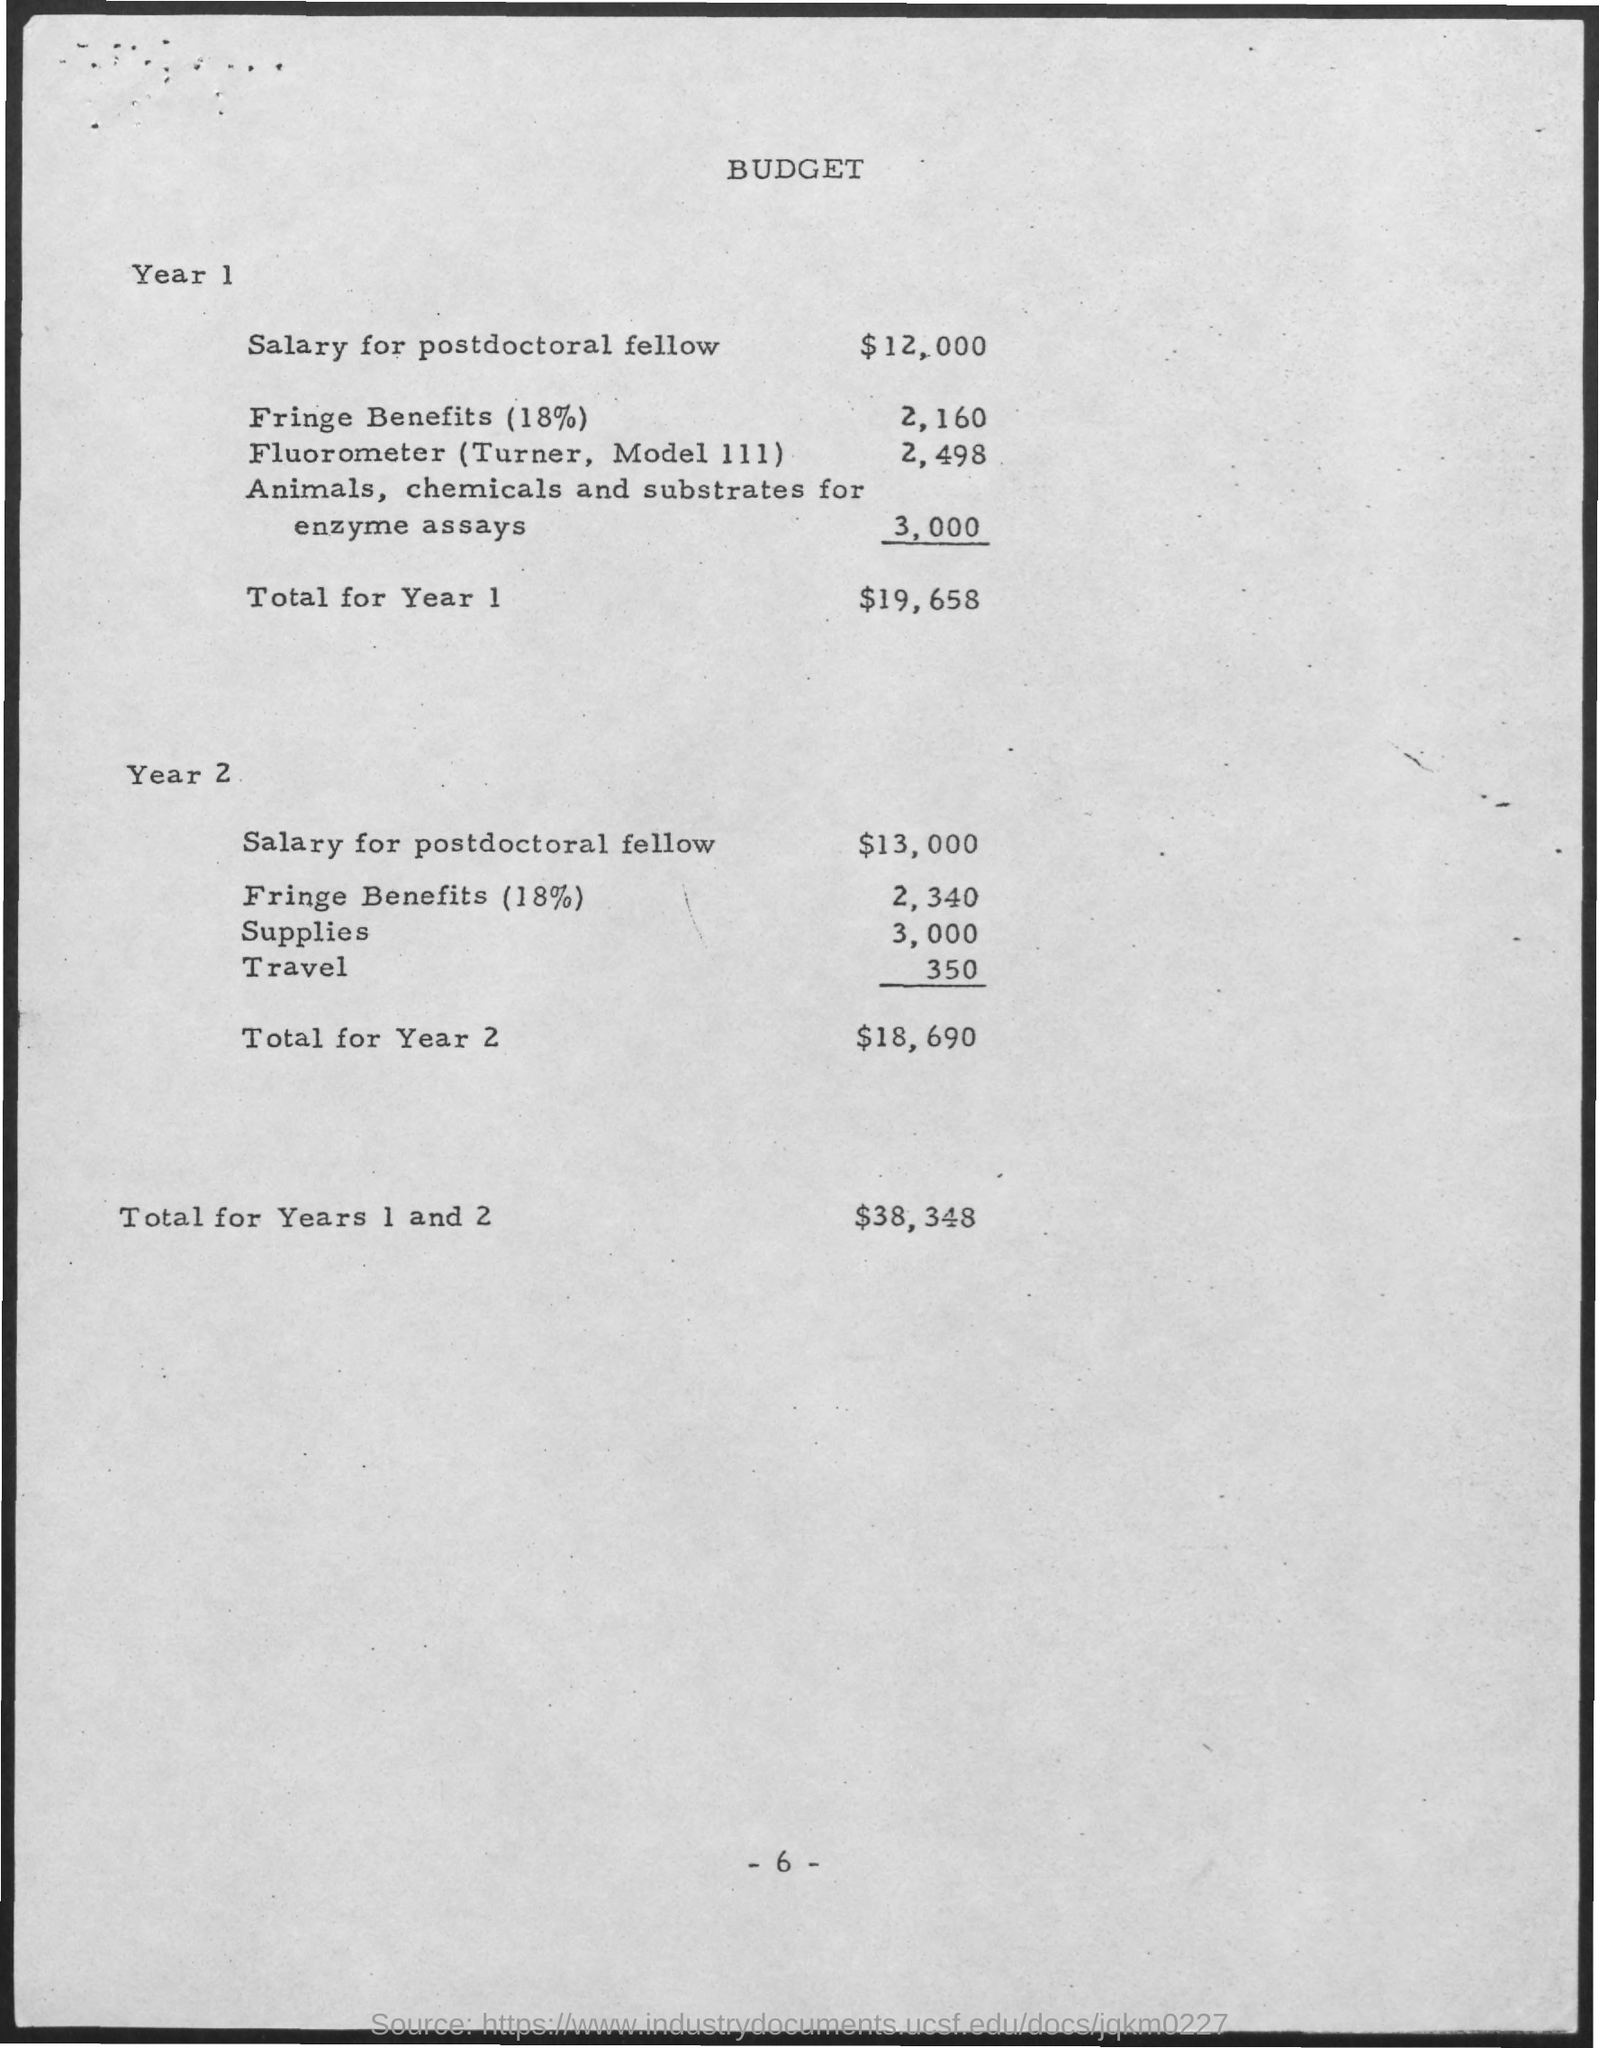Identify some key points in this picture. The total for year 2 is $18,690. As of the second year of the postdoctoral fellowship, the salary is $13,000. The total for year 1 is $19,658. The fringe benefits for Year 1 are 2,160. The supplies for Year 2 are expected to total 3,000. 